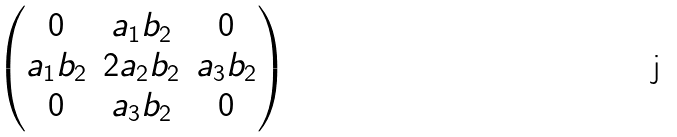<formula> <loc_0><loc_0><loc_500><loc_500>\begin{pmatrix} 0 & a _ { 1 } b _ { 2 } & 0 \\ a _ { 1 } b _ { 2 } & 2 a _ { 2 } b _ { 2 } & a _ { 3 } b _ { 2 } \\ 0 & a _ { 3 } b _ { 2 } & 0 \end{pmatrix}</formula> 